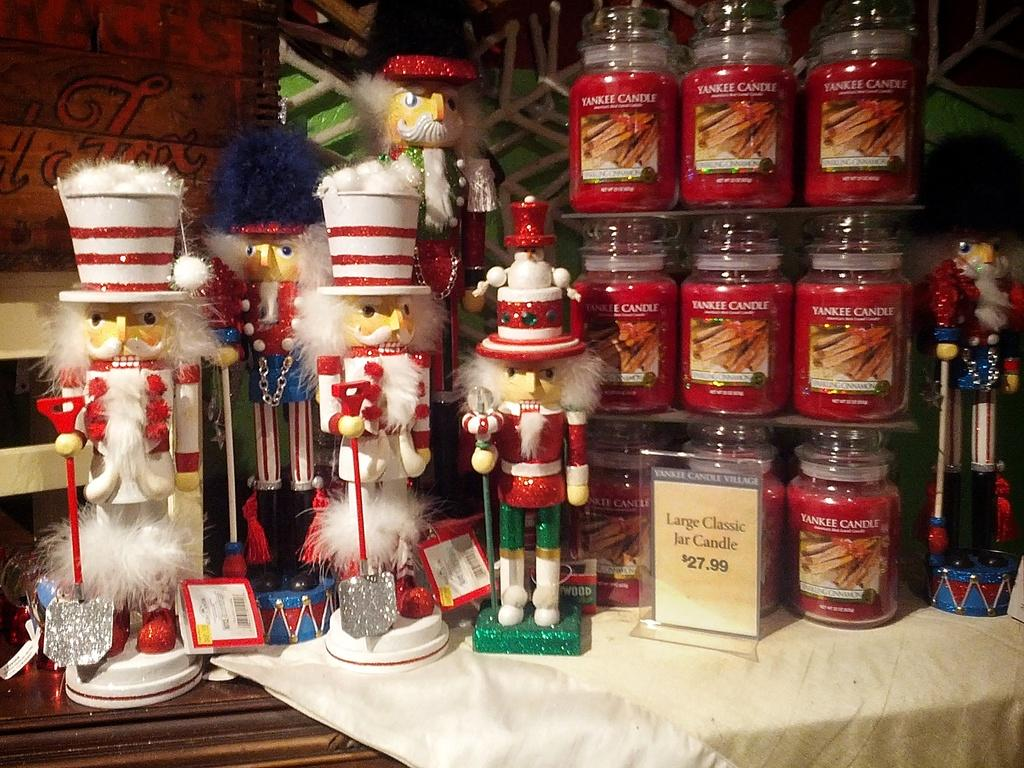<image>
Describe the image concisely. Wooden nutcrackers stand next to some red Yankee candles. 